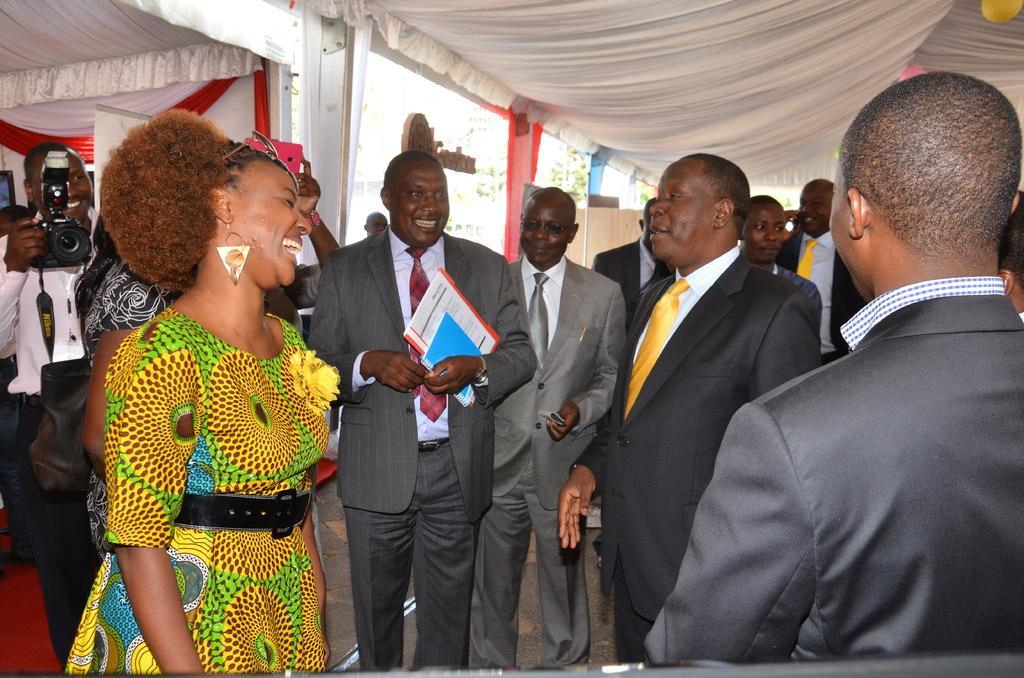Can you describe this image briefly? In this image I can see many people are standing under the tent and smiling. A man is holding books in the hand. On the left side there is a man holding a camera in the hand. 